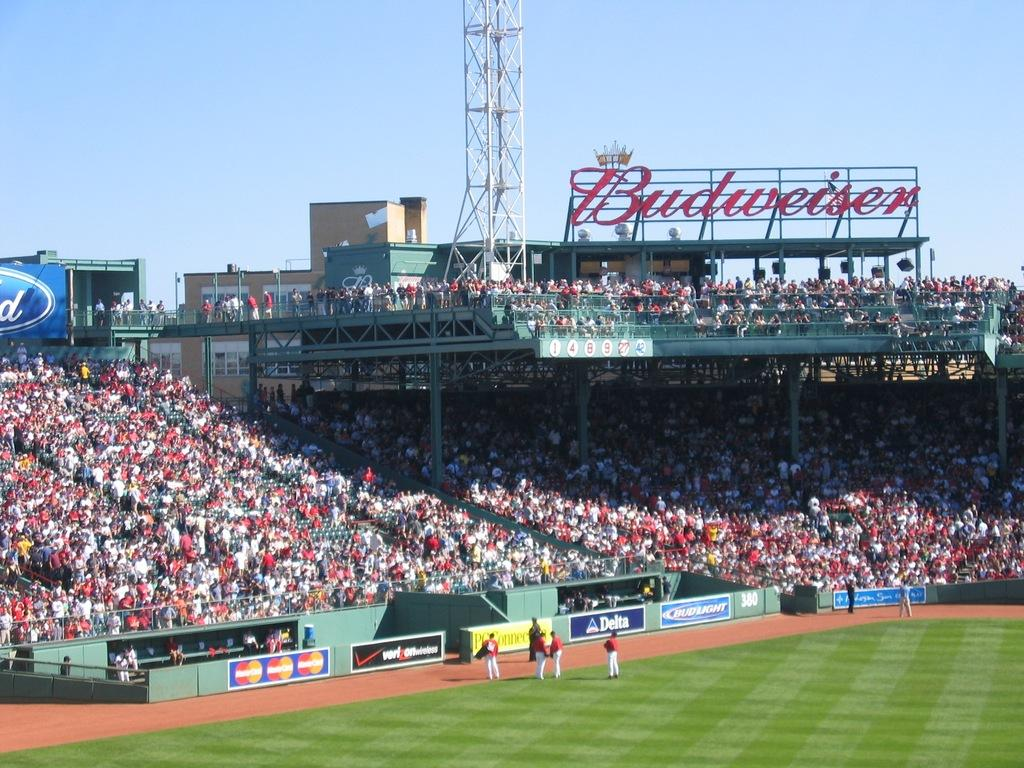<image>
Write a terse but informative summary of the picture. A Budweiser sign stands high above the stadium bleachers. 